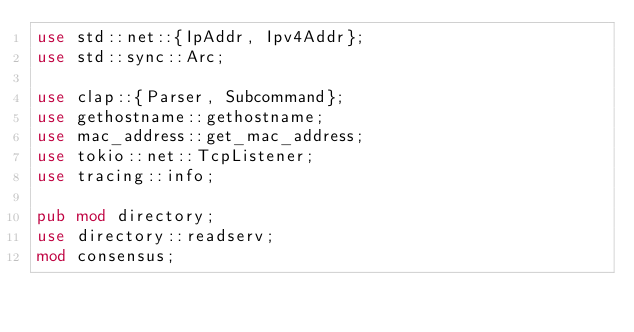<code> <loc_0><loc_0><loc_500><loc_500><_Rust_>use std::net::{IpAddr, Ipv4Addr};
use std::sync::Arc;

use clap::{Parser, Subcommand};
use gethostname::gethostname;
use mac_address::get_mac_address;
use tokio::net::TcpListener;
use tracing::info;

pub mod directory;
use directory::readserv;
mod consensus;</code> 